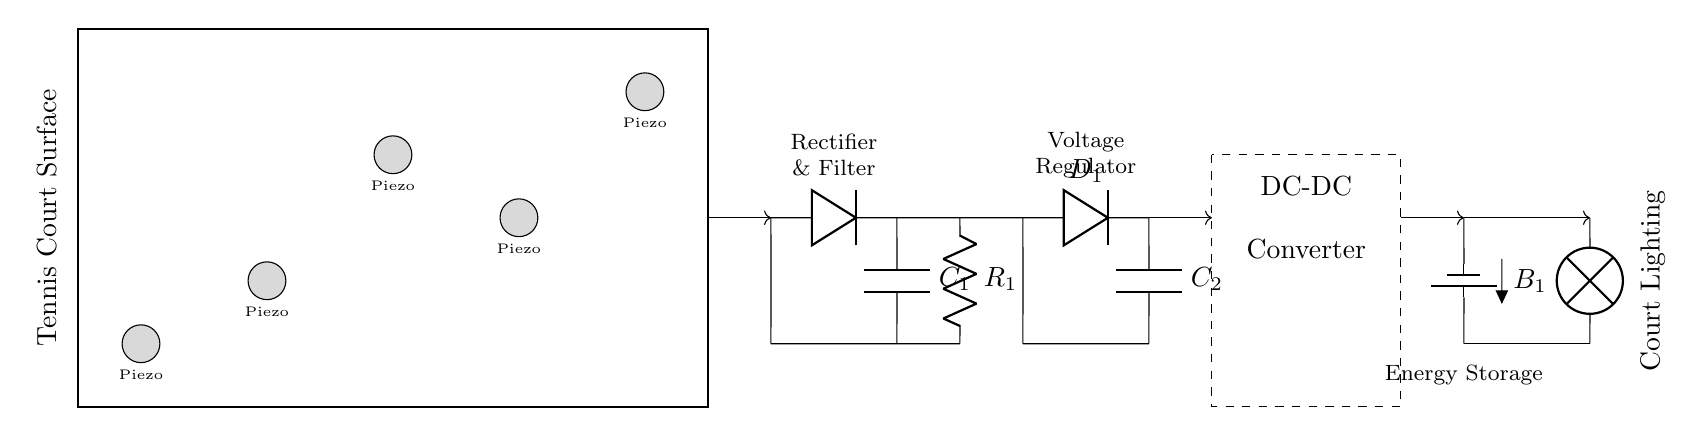What components are present in the energy harvesting system? The circuit includes piezoelectric sensors, a diode, capacitors, a resistor, a battery, a DC-DC converter, and a lamp, as clearly indicated in the diagram.
Answer: Piezoelectric sensors, diode, capacitors, resistor, battery, DC-DC converter, lamp How many piezoelectric sensors are there? The diagram shows five piezoelectric sensors labeled within the tennis court surface marked by circles, counted easily.
Answer: Five What type of energy conversion occurs in this circuit? The circuit converts mechanical energy from foot traffic on the tennis court into electrical energy using the piezoelectric sensors, which generates voltage when stressed.
Answer: Mechanical to electrical What is the purpose of the capacitor in this circuit? Capacitors are used for smoothing the charge from the piezoelectric sensors after rectification, ensuring a more stable voltage supply to the rest of the circuit components.
Answer: Smoothing charge Which component is responsible for voltage regulation? The DC-DC converter is specifically marked in the diagram for the purpose of regulating and stabilizing the voltage output to be usable for the energy storage and lighting system.
Answer: DC-DC converter What role does the battery play in this circuit? The battery stores electrical energy produced by the piezoelectric sensors for later use when lighting is required, functioning as a component of energy storage.
Answer: Energy storage Explain how the lighting is powered once the sensors generate energy. Energy from the piezoelectric sensors passes through the diode for rectification to convert AC to DC, is stored in capacitors and the battery, then regulated by the DC-DC converter before finally powering the lamp for court lighting.
Answer: Through rectification, storage, regulation, and powering the lamp 